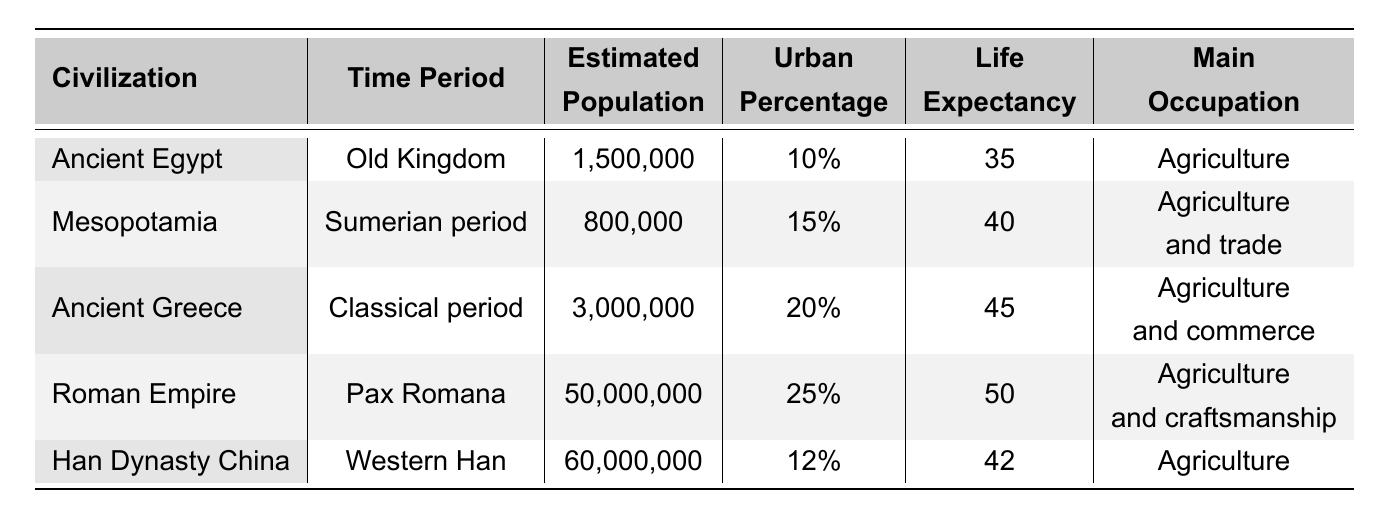What civilization has the highest estimated population? The table shows the estimated populations for each civilization. The Roman Empire has an estimated population of 50,000,000, which is higher than all the others listed.
Answer: Roman Empire What is the urban percentage of Ancient Greece? According to the table, Ancient Greece has an urban percentage of 20%. This value is directly provided in the corresponding row.
Answer: 20% Which civilization had the lowest life expectancy? The table indicates the life expectancy for each civilization. Ancient Egypt has the lowest life expectancy at 35 years.
Answer: Ancient Egypt Calculate the average life expectancy of the civilizations listed. The life expectancies are: 35, 40, 45, 50, and 42. The average is calculated as (35 + 40 + 45 + 50 + 42) / 5 = 42.4, but rounding gives us about 42.
Answer: 42 Is the main occupation of Han Dynasty China agriculture? Looking at the table, the main occupation for Han Dynasty China is listed as agriculture. This statement is true based on the data provided.
Answer: Yes Which civilization has a higher urban percentage, Mesopotamia or Ancient Egypt? The urban percentage for Mesopotamia is 15%, while Ancient Egypt's urban percentage is 10%. Therefore, Mesopotamia has a higher urban percentage.
Answer: Mesopotamia If you combine the estimated populations of Ancient Egypt and Mesopotamia, what would the total be? The estimated population of Ancient Egypt is 1,500,000 and Mesopotamia is 800,000. The total is calculated as 1,500,000 + 800,000 = 2,300,000.
Answer: 2,300,000 Which civilization had a more complex social stratification: the Roman Empire or Ancient Greece? The table indicates that the Roman Empire has a "Complex hierarchy," whereas Ancient Greece is described as "Citizen-based." Therefore, the Roman Empire had a more complex social stratification.
Answer: Roman Empire How does the life expectancy of the Roman Empire compare to that of Han Dynasty China? The life expectancy of the Roman Empire is 50 years, whereas Han Dynasty China's life expectancy is 42 years. The Roman Empire has a higher life expectancy by 8 years.
Answer: Roman Empire has higher life expectancy What percentage of the estimated population of the Han Dynasty China can be attributed to its urban population? For Han Dynasty China, the urban percentage is 12% of the total population of 60,000,000. Calculating this gives 60,000,000 * 0.12 = 7,200,000.
Answer: 7,200,000 